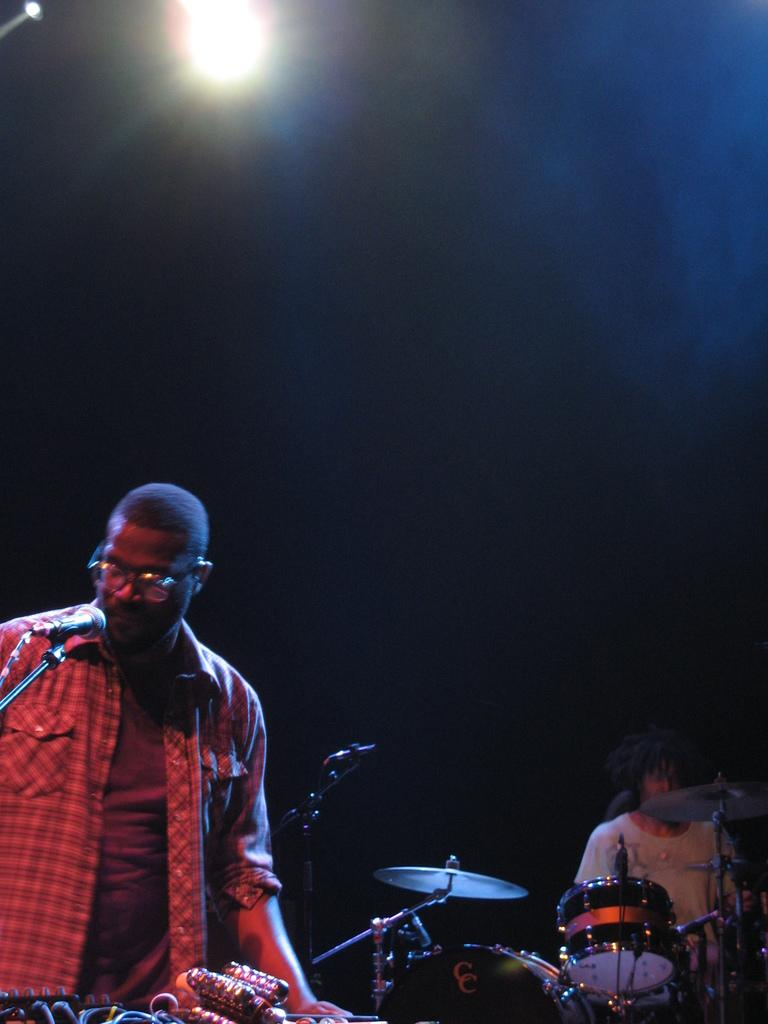How many people are in the image? There are two men in the image. What are the men doing in the image? One of the men is playing drums. What objects are in front of the men? There are microphones (mics) in front of the men. What can be observed about the background of the image? The background of the image is dark. What type of brass instrument is being played by the second man in the image? There is no second man playing a brass instrument in the image; only one man is playing drums. Can you see a flame coming from the drumsticks in the image? There is no flame present in the image; the drummer is using drumsticks to play the drums. 